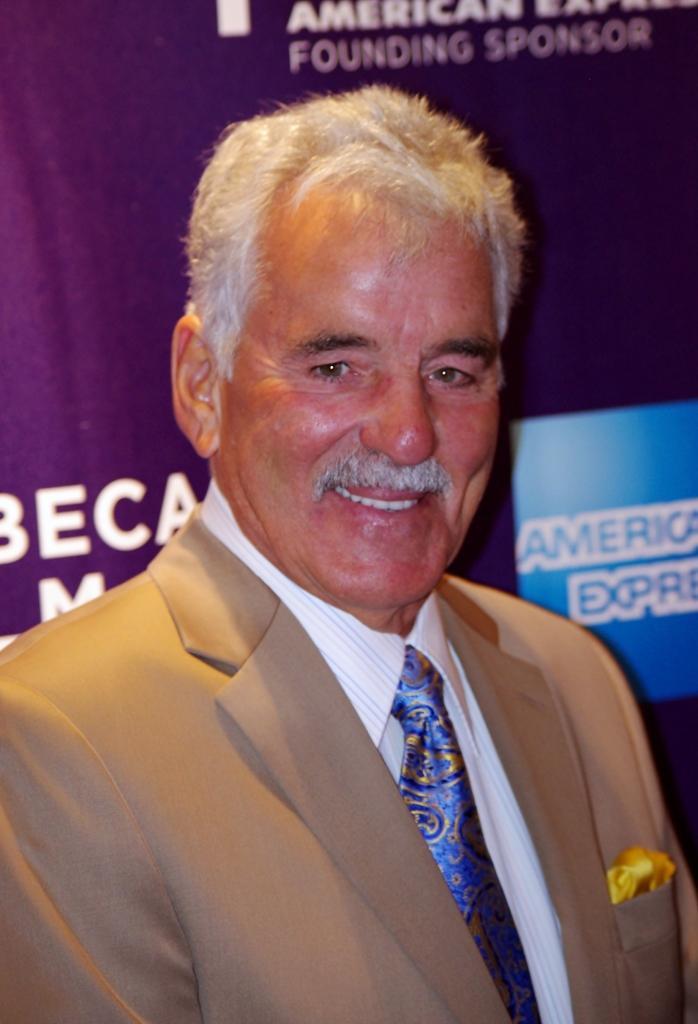Describe this image in one or two sentences. A man is standing wearing suit. 